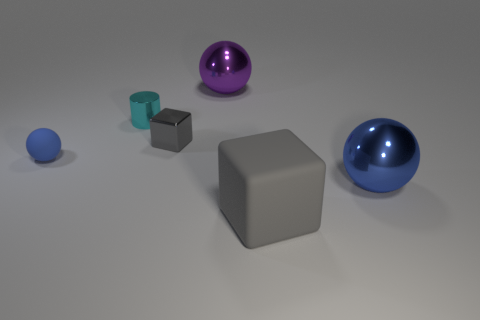How many blue balls must be subtracted to get 1 blue balls? 1 Add 4 big brown matte cylinders. How many objects exist? 10 Subtract all cubes. How many objects are left? 4 Subtract all balls. Subtract all large gray rubber objects. How many objects are left? 2 Add 1 rubber objects. How many rubber objects are left? 3 Add 1 big brown metal cylinders. How many big brown metal cylinders exist? 1 Subtract 0 purple cubes. How many objects are left? 6 